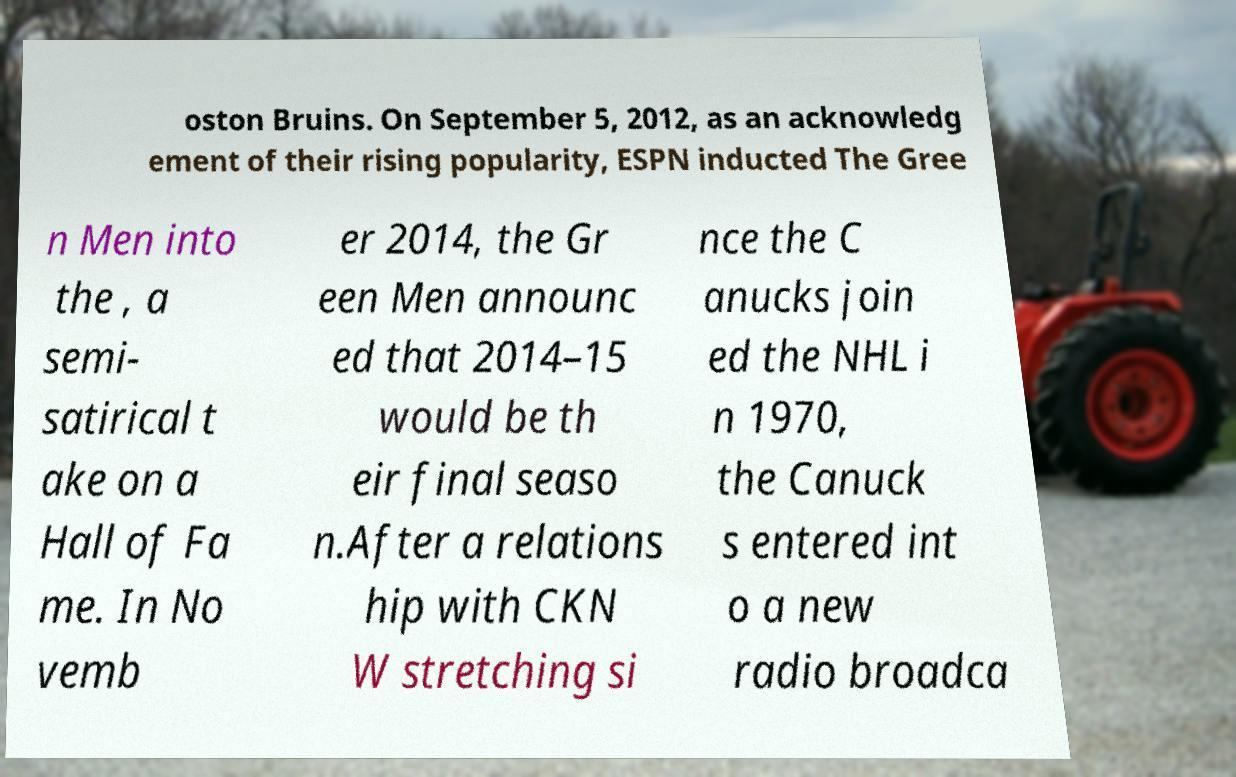Please identify and transcribe the text found in this image. oston Bruins. On September 5, 2012, as an acknowledg ement of their rising popularity, ESPN inducted The Gree n Men into the , a semi- satirical t ake on a Hall of Fa me. In No vemb er 2014, the Gr een Men announc ed that 2014–15 would be th eir final seaso n.After a relations hip with CKN W stretching si nce the C anucks join ed the NHL i n 1970, the Canuck s entered int o a new radio broadca 